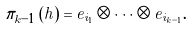<formula> <loc_0><loc_0><loc_500><loc_500>\pi _ { k - 1 } \left ( h \right ) = e _ { i _ { 1 } } \otimes \dots \otimes e _ { i _ { k - 1 } } .</formula> 